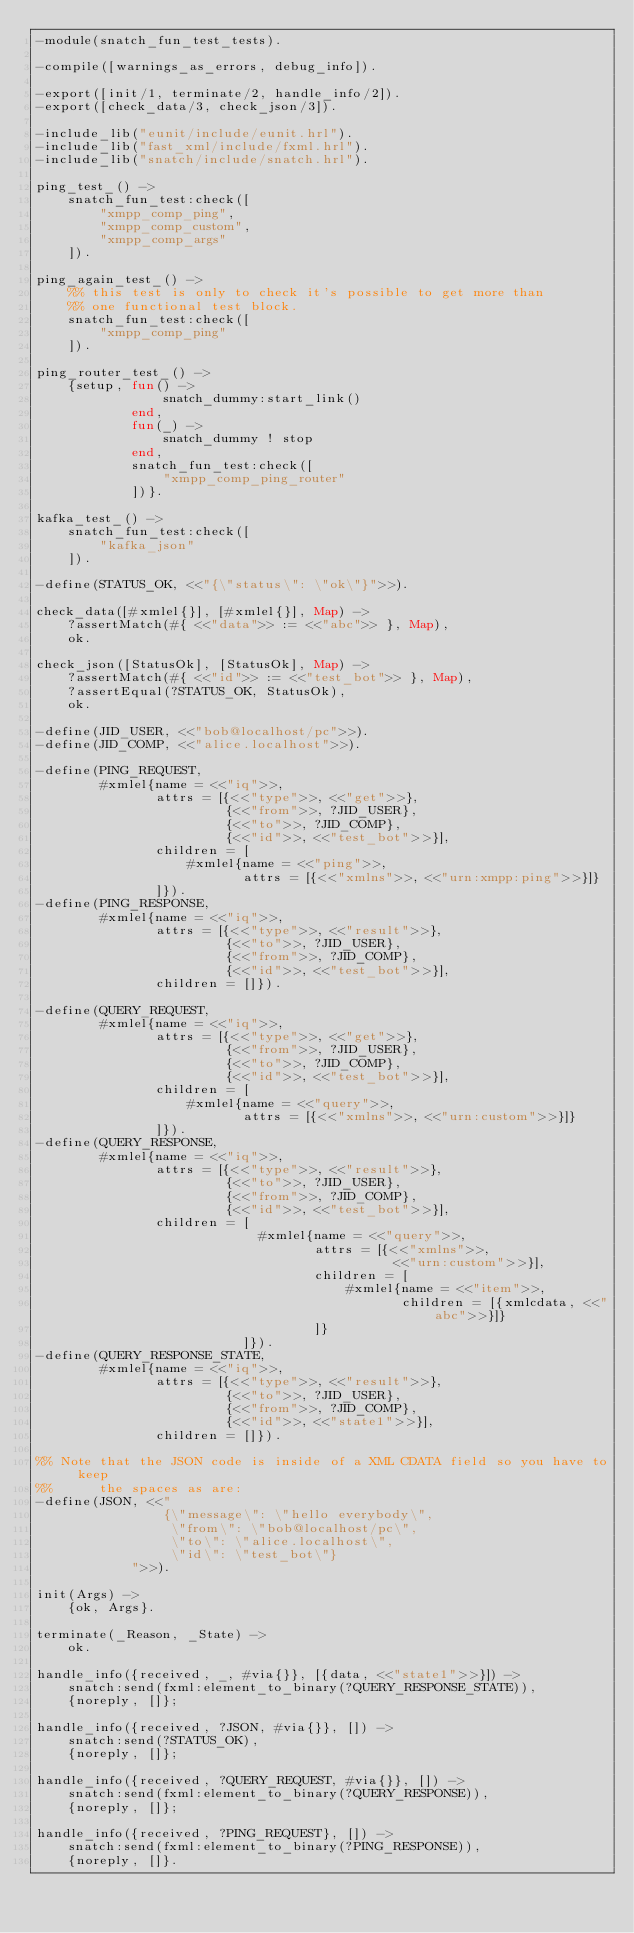Convert code to text. <code><loc_0><loc_0><loc_500><loc_500><_Erlang_>-module(snatch_fun_test_tests).

-compile([warnings_as_errors, debug_info]).

-export([init/1, terminate/2, handle_info/2]).
-export([check_data/3, check_json/3]).

-include_lib("eunit/include/eunit.hrl").
-include_lib("fast_xml/include/fxml.hrl").
-include_lib("snatch/include/snatch.hrl").

ping_test_() ->
    snatch_fun_test:check([
        "xmpp_comp_ping",
        "xmpp_comp_custom",
        "xmpp_comp_args"
    ]).

ping_again_test_() ->
    %% this test is only to check it's possible to get more than
    %% one functional test block.
    snatch_fun_test:check([
        "xmpp_comp_ping"
    ]).

ping_router_test_() ->
    {setup, fun() ->
                snatch_dummy:start_link()
            end,
            fun(_) ->
                snatch_dummy ! stop
            end,
            snatch_fun_test:check([
                "xmpp_comp_ping_router"
            ])}.

kafka_test_() ->
    snatch_fun_test:check([
        "kafka_json"
    ]).

-define(STATUS_OK, <<"{\"status\": \"ok\"}">>).

check_data([#xmlel{}], [#xmlel{}], Map) ->
    ?assertMatch(#{ <<"data">> := <<"abc">> }, Map),
    ok.

check_json([StatusOk], [StatusOk], Map) ->
    ?assertMatch(#{ <<"id">> := <<"test_bot">> }, Map),
    ?assertEqual(?STATUS_OK, StatusOk),
    ok.

-define(JID_USER, <<"bob@localhost/pc">>).
-define(JID_COMP, <<"alice.localhost">>).

-define(PING_REQUEST,
        #xmlel{name = <<"iq">>,
               attrs = [{<<"type">>, <<"get">>},
                        {<<"from">>, ?JID_USER},
                        {<<"to">>, ?JID_COMP},
                        {<<"id">>, <<"test_bot">>}],
               children = [
                   #xmlel{name = <<"ping">>,
                          attrs = [{<<"xmlns">>, <<"urn:xmpp:ping">>}]}
               ]}).
-define(PING_RESPONSE,
        #xmlel{name = <<"iq">>,
               attrs = [{<<"type">>, <<"result">>},
                        {<<"to">>, ?JID_USER},
                        {<<"from">>, ?JID_COMP},
                        {<<"id">>, <<"test_bot">>}],
               children = []}).

-define(QUERY_REQUEST,
        #xmlel{name = <<"iq">>,
               attrs = [{<<"type">>, <<"get">>},
                        {<<"from">>, ?JID_USER},
                        {<<"to">>, ?JID_COMP},
                        {<<"id">>, <<"test_bot">>}],
               children = [
                   #xmlel{name = <<"query">>,
                          attrs = [{<<"xmlns">>, <<"urn:custom">>}]}
               ]}).
-define(QUERY_RESPONSE,
        #xmlel{name = <<"iq">>,
               attrs = [{<<"type">>, <<"result">>},
                        {<<"to">>, ?JID_USER},
                        {<<"from">>, ?JID_COMP},
                        {<<"id">>, <<"test_bot">>}],
               children = [
                            #xmlel{name = <<"query">>,
                                   attrs = [{<<"xmlns">>,
                                             <<"urn:custom">>}],
                                   children = [
                                       #xmlel{name = <<"item">>,
                                              children = [{xmlcdata, <<"abc">>}]}
                                   ]}
                          ]}).
-define(QUERY_RESPONSE_STATE,
        #xmlel{name = <<"iq">>,
               attrs = [{<<"type">>, <<"result">>},
                        {<<"to">>, ?JID_USER},
                        {<<"from">>, ?JID_COMP},
                        {<<"id">>, <<"state1">>}],
               children = []}).

%% Note that the JSON code is inside of a XML CDATA field so you have to keep
%%      the spaces as are:
-define(JSON, <<"
                {\"message\": \"hello everybody\",
                 \"from\": \"bob@localhost/pc\",
                 \"to\": \"alice.localhost\",
                 \"id\": \"test_bot\"}
            ">>).

init(Args) ->
    {ok, Args}.

terminate(_Reason, _State) ->
    ok.

handle_info({received, _, #via{}}, [{data, <<"state1">>}]) ->
    snatch:send(fxml:element_to_binary(?QUERY_RESPONSE_STATE)),
    {noreply, []};

handle_info({received, ?JSON, #via{}}, []) ->
    snatch:send(?STATUS_OK),
    {noreply, []};

handle_info({received, ?QUERY_REQUEST, #via{}}, []) ->
    snatch:send(fxml:element_to_binary(?QUERY_RESPONSE)),
    {noreply, []};

handle_info({received, ?PING_REQUEST}, []) ->
    snatch:send(fxml:element_to_binary(?PING_RESPONSE)),
    {noreply, []}.
</code> 